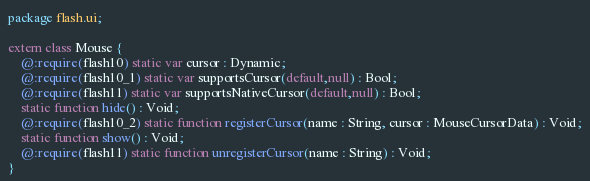Convert code to text. <code><loc_0><loc_0><loc_500><loc_500><_Haxe_>package flash.ui;

extern class Mouse {
	@:require(flash10) static var cursor : Dynamic;
	@:require(flash10_1) static var supportsCursor(default,null) : Bool;
	@:require(flash11) static var supportsNativeCursor(default,null) : Bool;
	static function hide() : Void;
	@:require(flash10_2) static function registerCursor(name : String, cursor : MouseCursorData) : Void;
	static function show() : Void;
	@:require(flash11) static function unregisterCursor(name : String) : Void;
}
</code> 